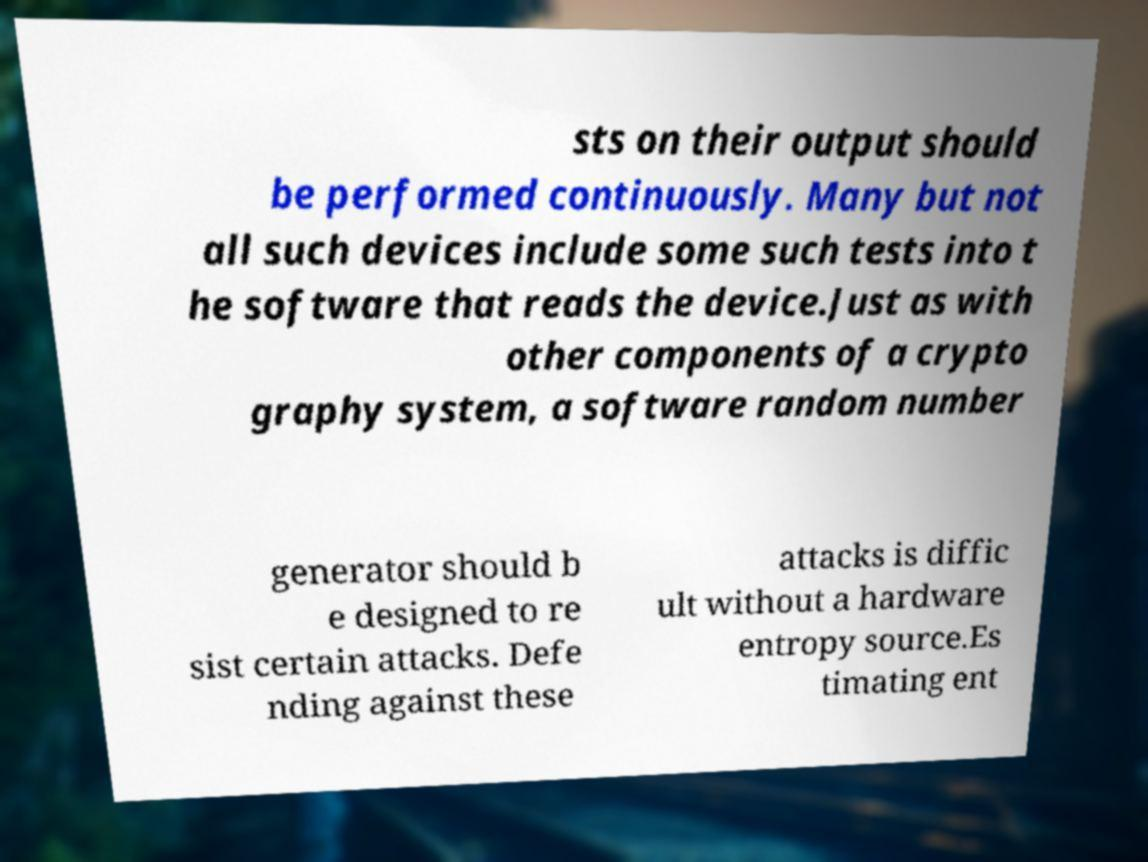There's text embedded in this image that I need extracted. Can you transcribe it verbatim? sts on their output should be performed continuously. Many but not all such devices include some such tests into t he software that reads the device.Just as with other components of a crypto graphy system, a software random number generator should b e designed to re sist certain attacks. Defe nding against these attacks is diffic ult without a hardware entropy source.Es timating ent 